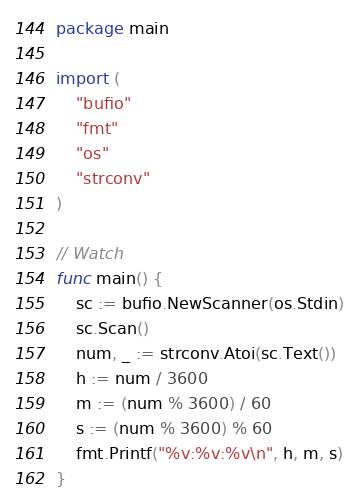<code> <loc_0><loc_0><loc_500><loc_500><_Go_>package main

import (
	"bufio"
	"fmt"
	"os"
	"strconv"
)

// Watch
func main() {
	sc := bufio.NewScanner(os.Stdin)
	sc.Scan()
	num, _ := strconv.Atoi(sc.Text())
	h := num / 3600
	m := (num % 3600) / 60
	s := (num % 3600) % 60
	fmt.Printf("%v:%v:%v\n", h, m, s)
}

</code> 